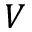Convert formula to latex. <formula><loc_0><loc_0><loc_500><loc_500>V</formula> 